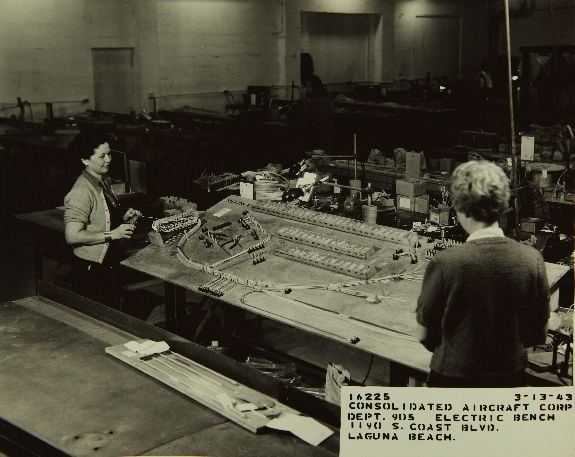Describe the objects in this image and their specific colors. I can see people in darkgray, black, and gray tones, people in darkgray, black, and gray tones, and bench in darkgray, gray, and beige tones in this image. 